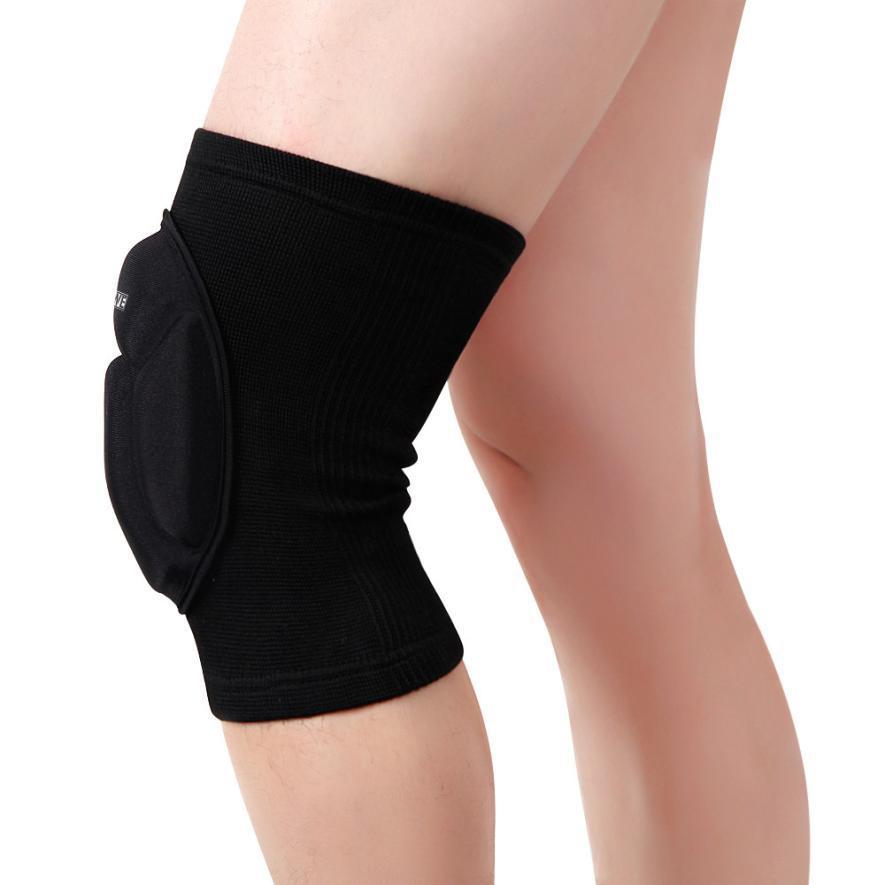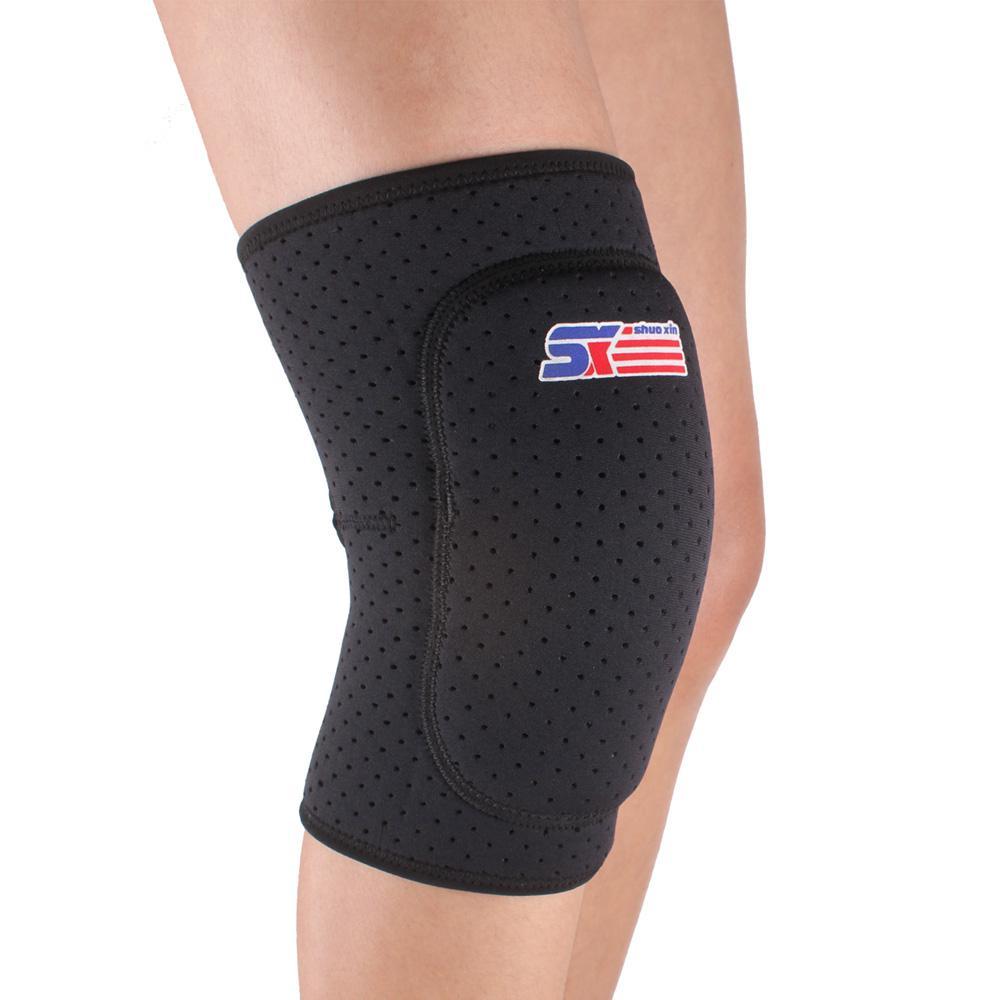The first image is the image on the left, the second image is the image on the right. For the images shown, is this caption "One of the knee-pads has Velcro around the top and one does not." true? Answer yes or no. No. 